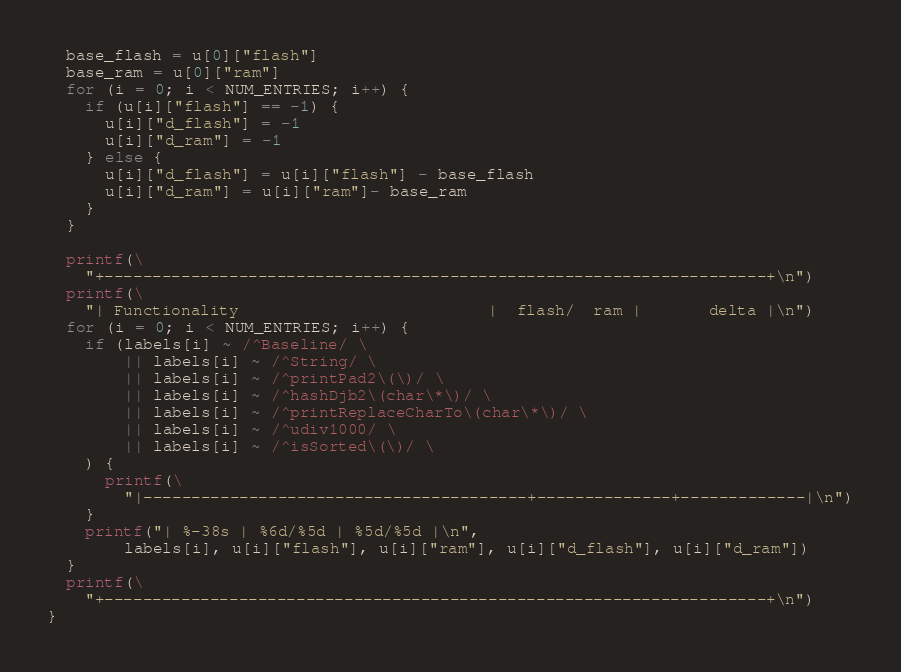Convert code to text. <code><loc_0><loc_0><loc_500><loc_500><_Awk_>  base_flash = u[0]["flash"]
  base_ram = u[0]["ram"]
  for (i = 0; i < NUM_ENTRIES; i++) {
    if (u[i]["flash"] == -1) {
      u[i]["d_flash"] = -1
      u[i]["d_ram"] = -1
    } else {
      u[i]["d_flash"] = u[i]["flash"] - base_flash
      u[i]["d_ram"] = u[i]["ram"]- base_ram
    }
  }

  printf(\
    "+---------------------------------------------------------------------+\n")
  printf(\
    "| Functionality                          |  flash/  ram |       delta |\n")
  for (i = 0; i < NUM_ENTRIES; i++) {
    if (labels[i] ~ /^Baseline/ \
        || labels[i] ~ /^String/ \
        || labels[i] ~ /^printPad2\(\)/ \
        || labels[i] ~ /^hashDjb2\(char\*\)/ \
        || labels[i] ~ /^printReplaceCharTo\(char\*\)/ \
        || labels[i] ~ /^udiv1000/ \
        || labels[i] ~ /^isSorted\(\)/ \
    ) {
      printf(\
        "|----------------------------------------+--------------+-------------|\n")
    }
    printf("| %-38s | %6d/%5d | %5d/%5d |\n",
        labels[i], u[i]["flash"], u[i]["ram"], u[i]["d_flash"], u[i]["d_ram"])
  }
  printf(\
    "+---------------------------------------------------------------------+\n")
}
</code> 